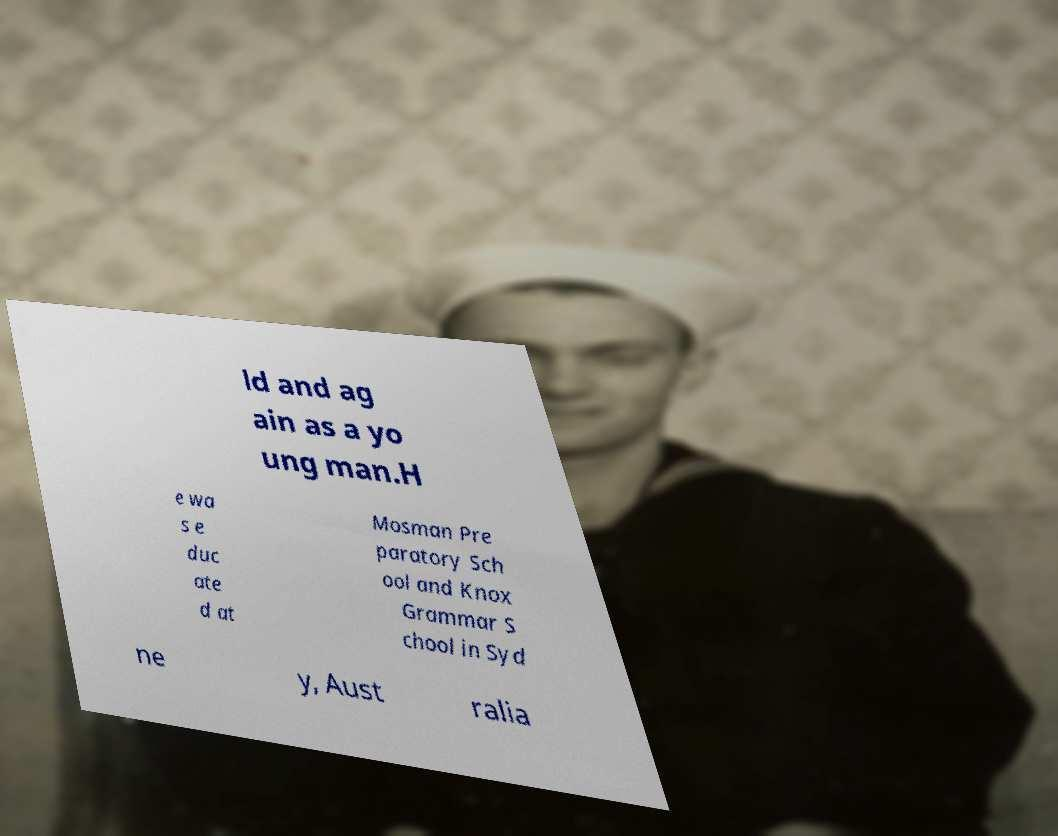Can you accurately transcribe the text from the provided image for me? ld and ag ain as a yo ung man.H e wa s e duc ate d at Mosman Pre paratory Sch ool and Knox Grammar S chool in Syd ne y, Aust ralia 